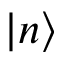<formula> <loc_0><loc_0><loc_500><loc_500>| n \rangle</formula> 